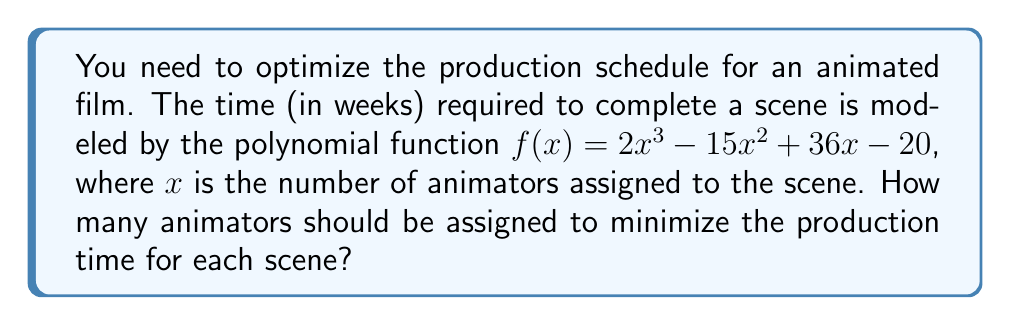Give your solution to this math problem. To find the minimum production time, we need to find the minimum point of the polynomial function. This occurs where the derivative of the function is zero.

1. Find the derivative of $f(x)$:
   $f'(x) = 6x^2 - 30x + 36$

2. Set the derivative equal to zero and solve:
   $6x^2 - 30x + 36 = 0$

3. This is a quadratic equation. We can solve it using the quadratic formula:
   $x = \frac{-b \pm \sqrt{b^2 - 4ac}}{2a}$

   Where $a = 6$, $b = -30$, and $c = 36$

4. Plugging in the values:
   $x = \frac{30 \pm \sqrt{(-30)^2 - 4(6)(36)}}{2(6)}$

5. Simplify:
   $x = \frac{30 \pm \sqrt{900 - 864}}{12} = \frac{30 \pm \sqrt{36}}{12} = \frac{30 \pm 6}{12}$

6. This gives us two solutions:
   $x_1 = \frac{30 + 6}{12} = 3$ and $x_2 = \frac{30 - 6}{12} = 2$

7. To determine which solution gives the minimum, we can check the second derivative:
   $f''(x) = 12x - 30$

8. At $x = 3$:
   $f''(3) = 12(3) - 30 = 6 > 0$

   This confirms that $x = 3$ gives the minimum point.

Therefore, assigning 3 animators to each scene will minimize the production time.
Answer: 3 animators 